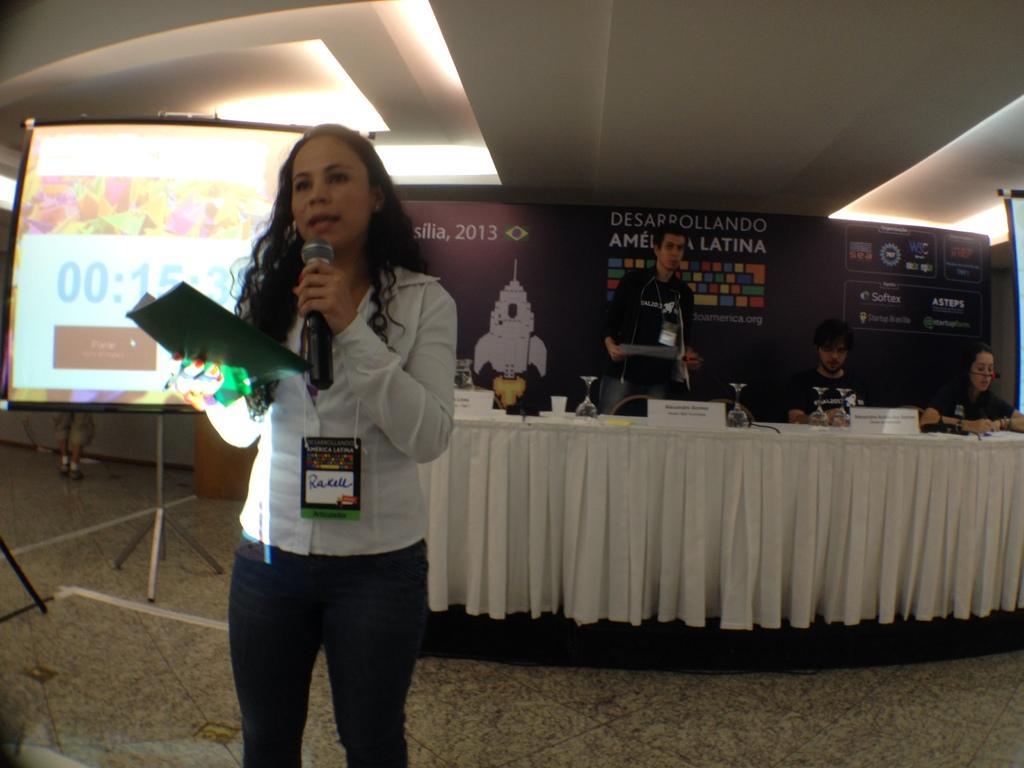Please provide a concise description of this image. In the image there is a woman in white shirt and black pant talking on mic in the front holding a file behind her and there are few persons sitting in front of table and on the left side there is a screen, on the background there is a banner on the wall and the ceiling has lights. 